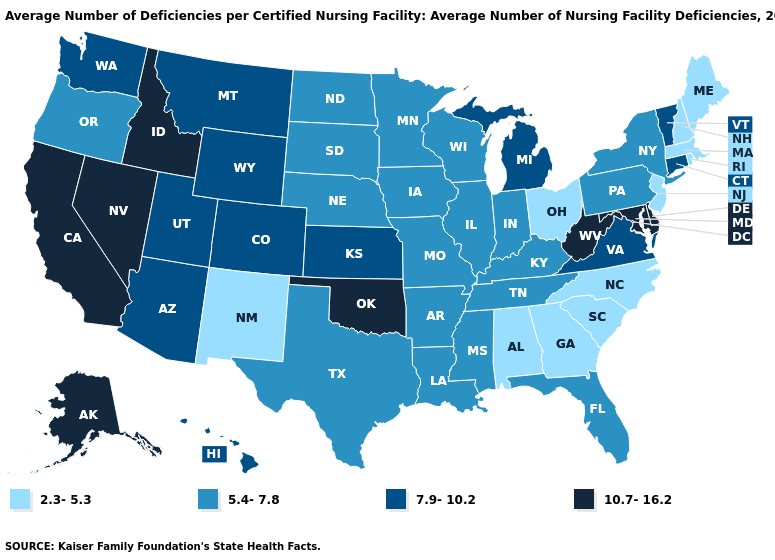What is the value of Maine?
Give a very brief answer. 2.3-5.3. Is the legend a continuous bar?
Write a very short answer. No. Among the states that border Tennessee , does North Carolina have the lowest value?
Give a very brief answer. Yes. What is the highest value in states that border North Carolina?
Short answer required. 7.9-10.2. Among the states that border South Carolina , which have the highest value?
Answer briefly. Georgia, North Carolina. Which states have the lowest value in the USA?
Answer briefly. Alabama, Georgia, Maine, Massachusetts, New Hampshire, New Jersey, New Mexico, North Carolina, Ohio, Rhode Island, South Carolina. Does Mississippi have a higher value than North Carolina?
Write a very short answer. Yes. Name the states that have a value in the range 5.4-7.8?
Give a very brief answer. Arkansas, Florida, Illinois, Indiana, Iowa, Kentucky, Louisiana, Minnesota, Mississippi, Missouri, Nebraska, New York, North Dakota, Oregon, Pennsylvania, South Dakota, Tennessee, Texas, Wisconsin. Does the map have missing data?
Concise answer only. No. What is the highest value in states that border Delaware?
Quick response, please. 10.7-16.2. Among the states that border Alabama , which have the lowest value?
Give a very brief answer. Georgia. Name the states that have a value in the range 5.4-7.8?
Give a very brief answer. Arkansas, Florida, Illinois, Indiana, Iowa, Kentucky, Louisiana, Minnesota, Mississippi, Missouri, Nebraska, New York, North Dakota, Oregon, Pennsylvania, South Dakota, Tennessee, Texas, Wisconsin. What is the value of Illinois?
Be succinct. 5.4-7.8. Name the states that have a value in the range 5.4-7.8?
Write a very short answer. Arkansas, Florida, Illinois, Indiana, Iowa, Kentucky, Louisiana, Minnesota, Mississippi, Missouri, Nebraska, New York, North Dakota, Oregon, Pennsylvania, South Dakota, Tennessee, Texas, Wisconsin. How many symbols are there in the legend?
Be succinct. 4. 